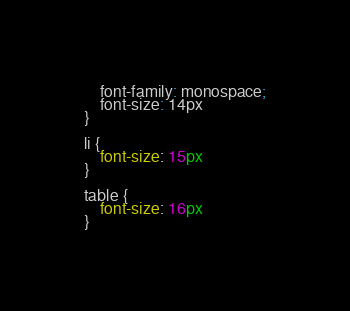<code> <loc_0><loc_0><loc_500><loc_500><_CSS_>    font-family: monospace;
    font-size: 14px
}

li {
    font-size: 15px
}

table {
    font-size: 16px
}
</code> 